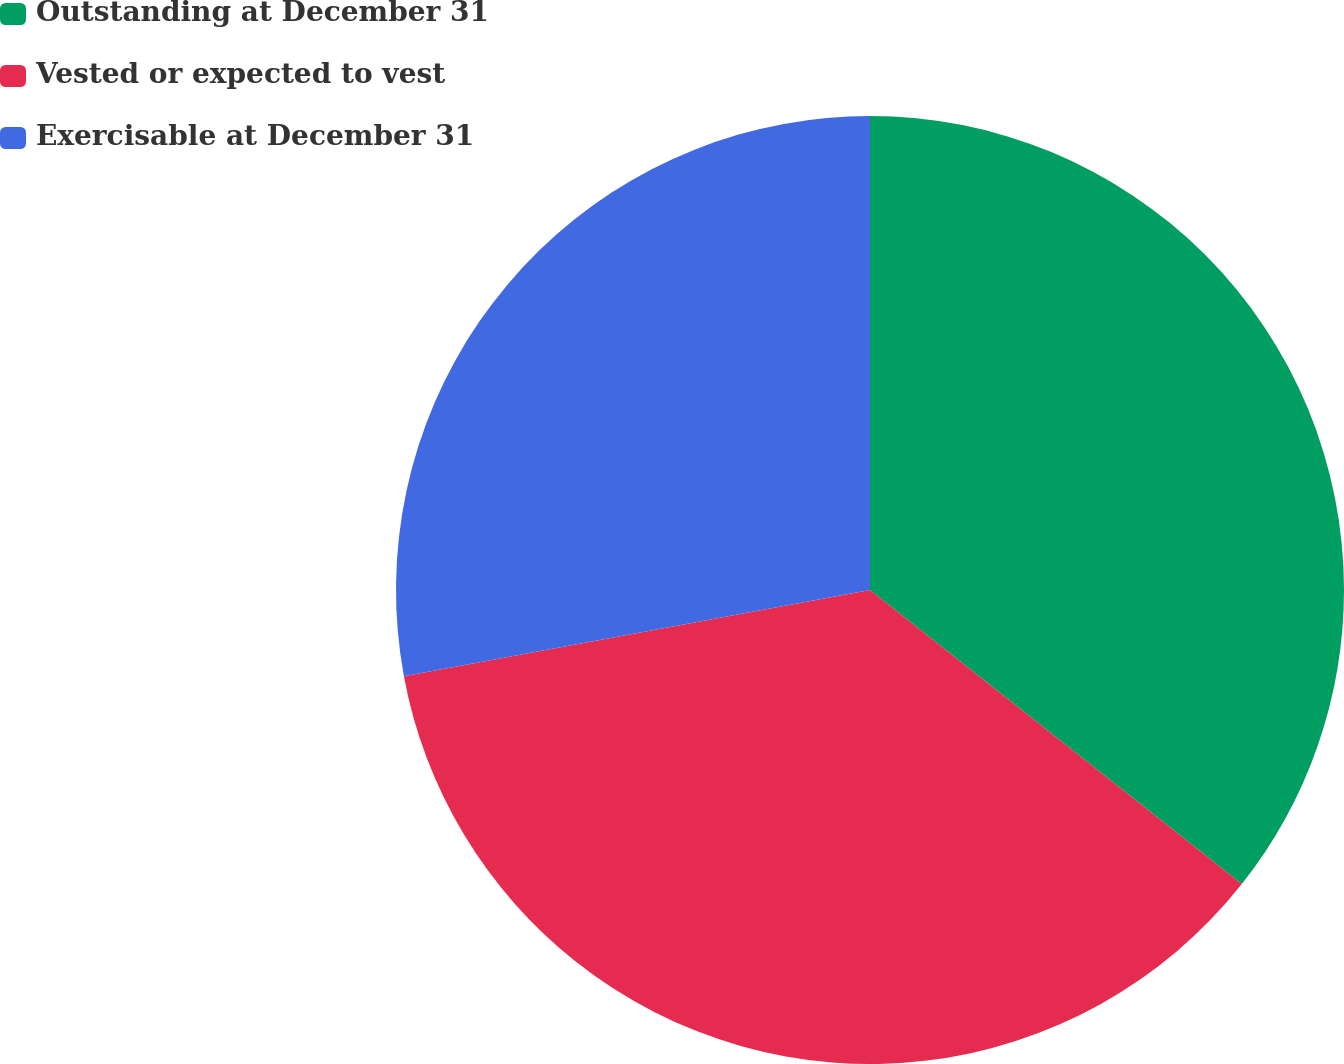Convert chart to OTSL. <chart><loc_0><loc_0><loc_500><loc_500><pie_chart><fcel>Outstanding at December 31<fcel>Vested or expected to vest<fcel>Exercisable at December 31<nl><fcel>35.65%<fcel>36.44%<fcel>27.91%<nl></chart> 